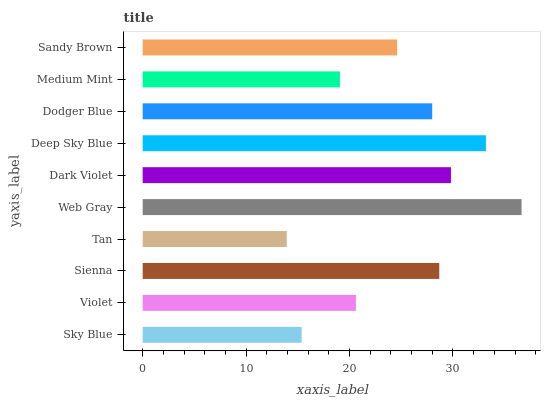Is Tan the minimum?
Answer yes or no. Yes. Is Web Gray the maximum?
Answer yes or no. Yes. Is Violet the minimum?
Answer yes or no. No. Is Violet the maximum?
Answer yes or no. No. Is Violet greater than Sky Blue?
Answer yes or no. Yes. Is Sky Blue less than Violet?
Answer yes or no. Yes. Is Sky Blue greater than Violet?
Answer yes or no. No. Is Violet less than Sky Blue?
Answer yes or no. No. Is Dodger Blue the high median?
Answer yes or no. Yes. Is Sandy Brown the low median?
Answer yes or no. Yes. Is Web Gray the high median?
Answer yes or no. No. Is Tan the low median?
Answer yes or no. No. 